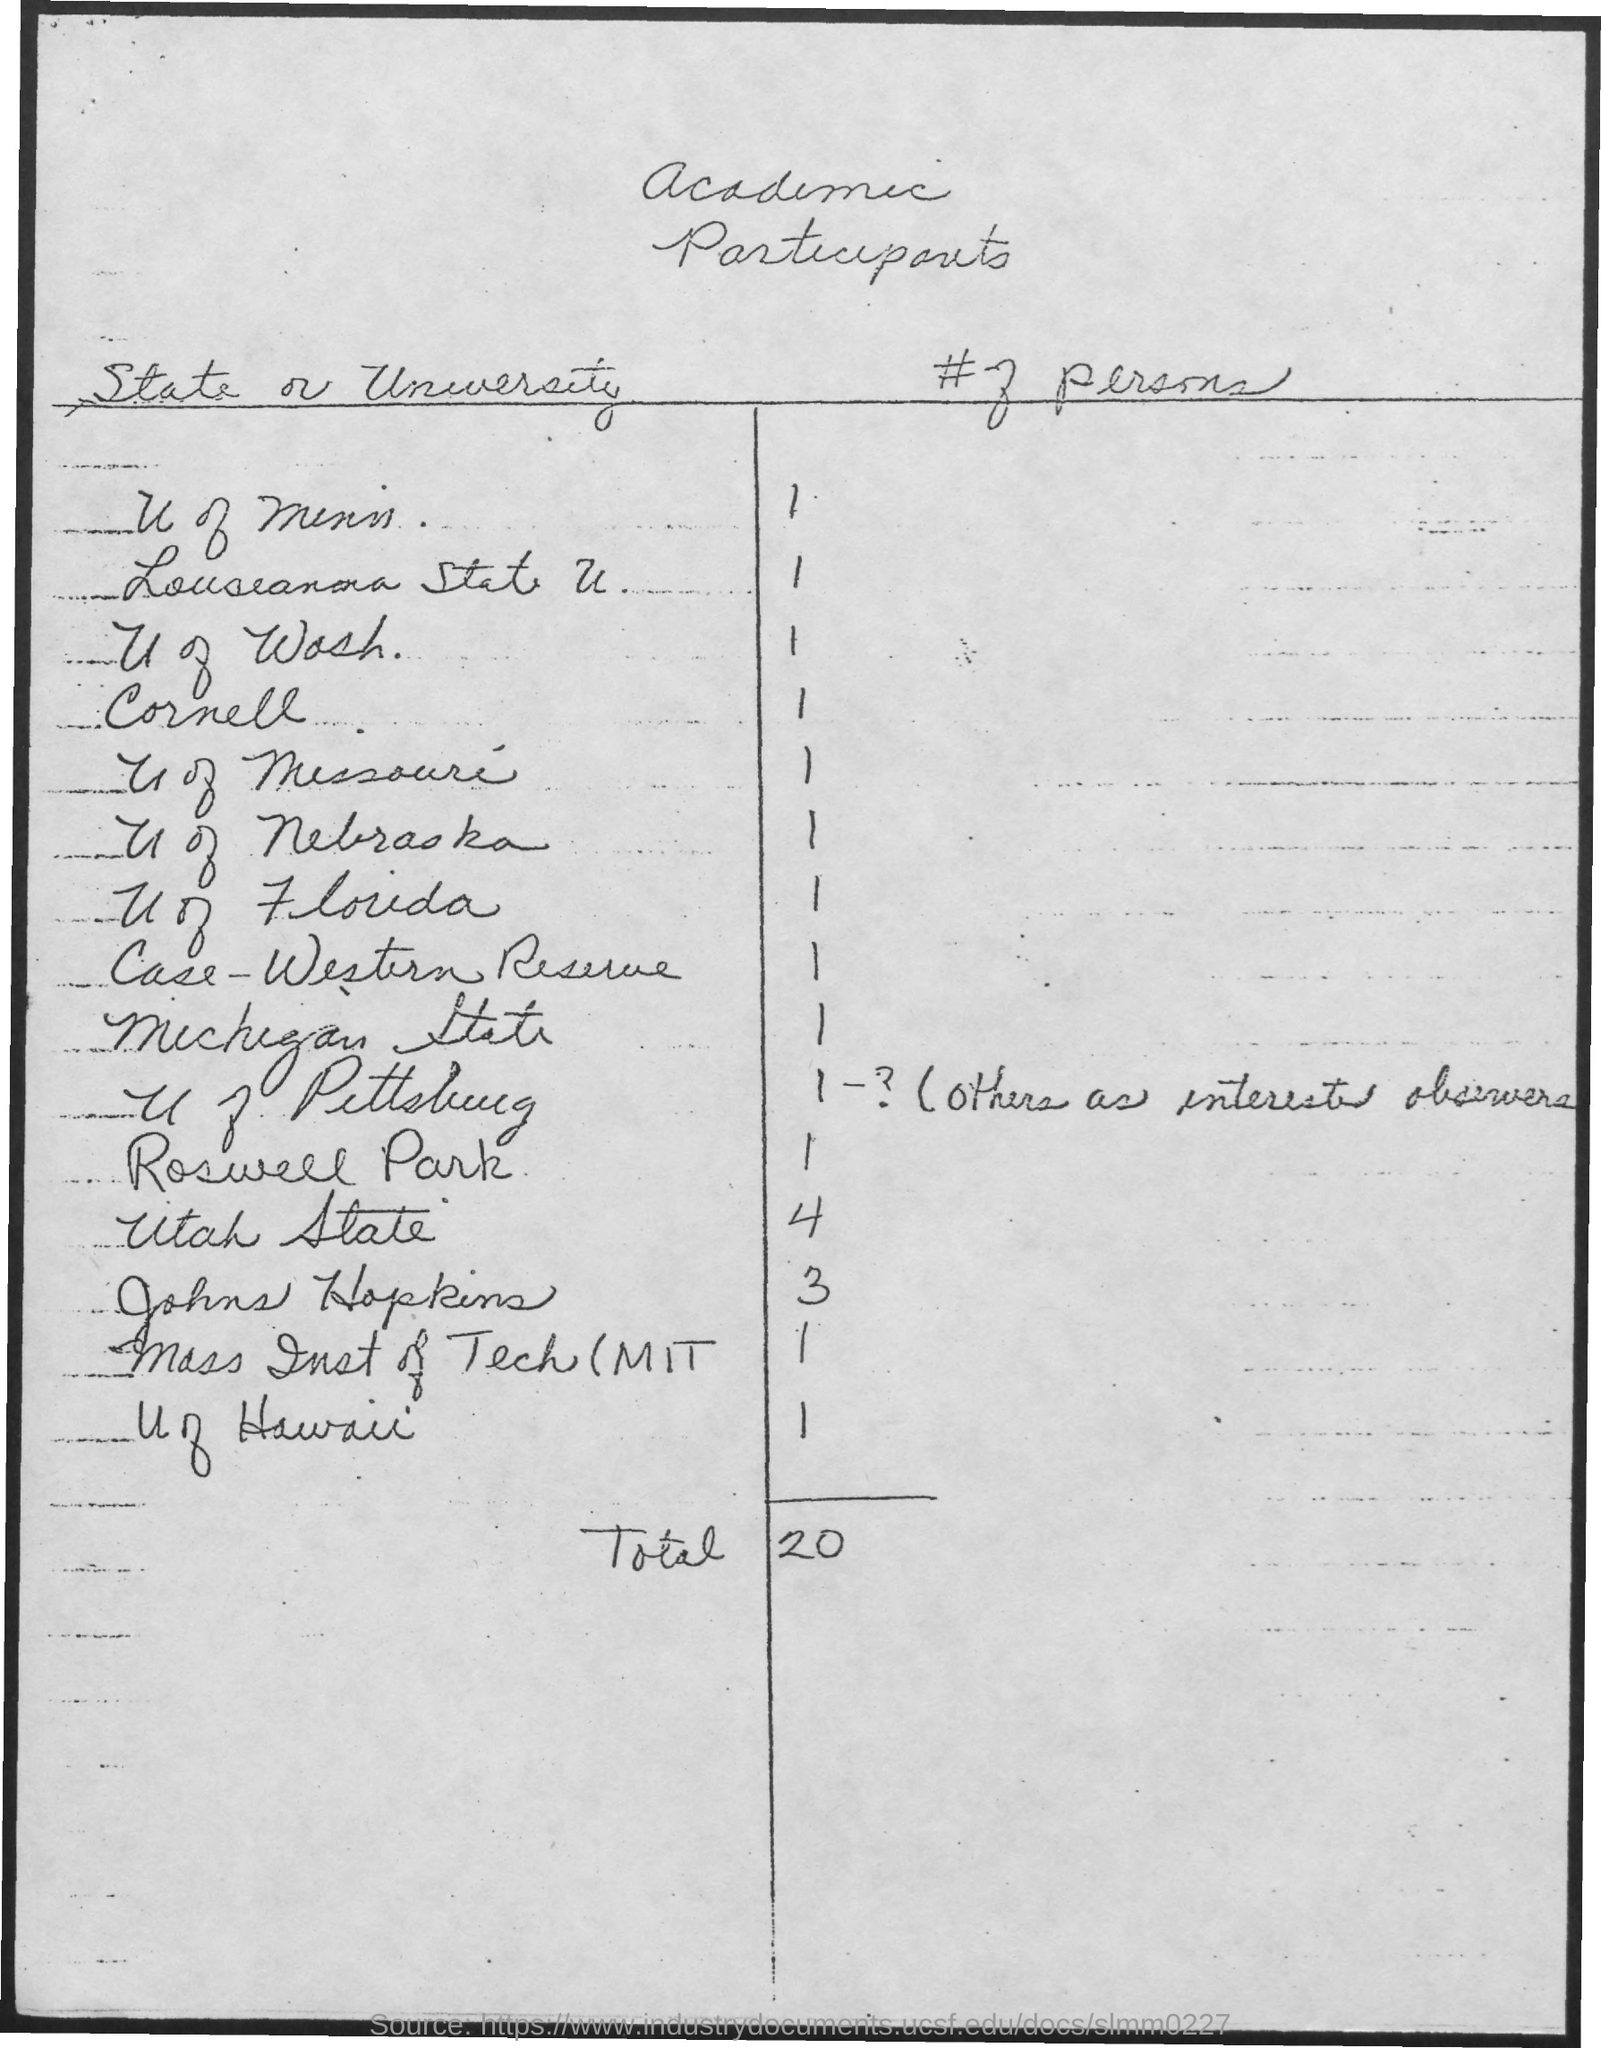Outline some significant characteristics in this image. Utah State has four participants. The total number of participants is 20. 